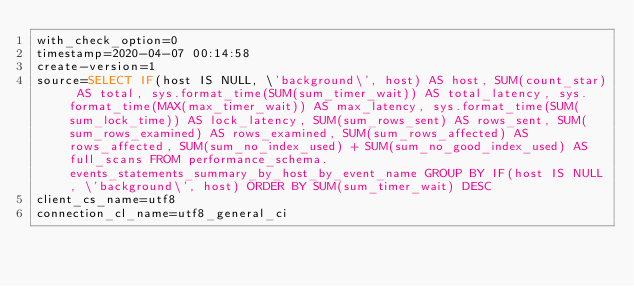<code> <loc_0><loc_0><loc_500><loc_500><_VisualBasic_>with_check_option=0
timestamp=2020-04-07 00:14:58
create-version=1
source=SELECT IF(host IS NULL, \'background\', host) AS host, SUM(count_star) AS total, sys.format_time(SUM(sum_timer_wait)) AS total_latency, sys.format_time(MAX(max_timer_wait)) AS max_latency, sys.format_time(SUM(sum_lock_time)) AS lock_latency, SUM(sum_rows_sent) AS rows_sent, SUM(sum_rows_examined) AS rows_examined, SUM(sum_rows_affected) AS rows_affected, SUM(sum_no_index_used) + SUM(sum_no_good_index_used) AS full_scans FROM performance_schema.events_statements_summary_by_host_by_event_name GROUP BY IF(host IS NULL, \'background\', host) ORDER BY SUM(sum_timer_wait) DESC
client_cs_name=utf8
connection_cl_name=utf8_general_ci</code> 